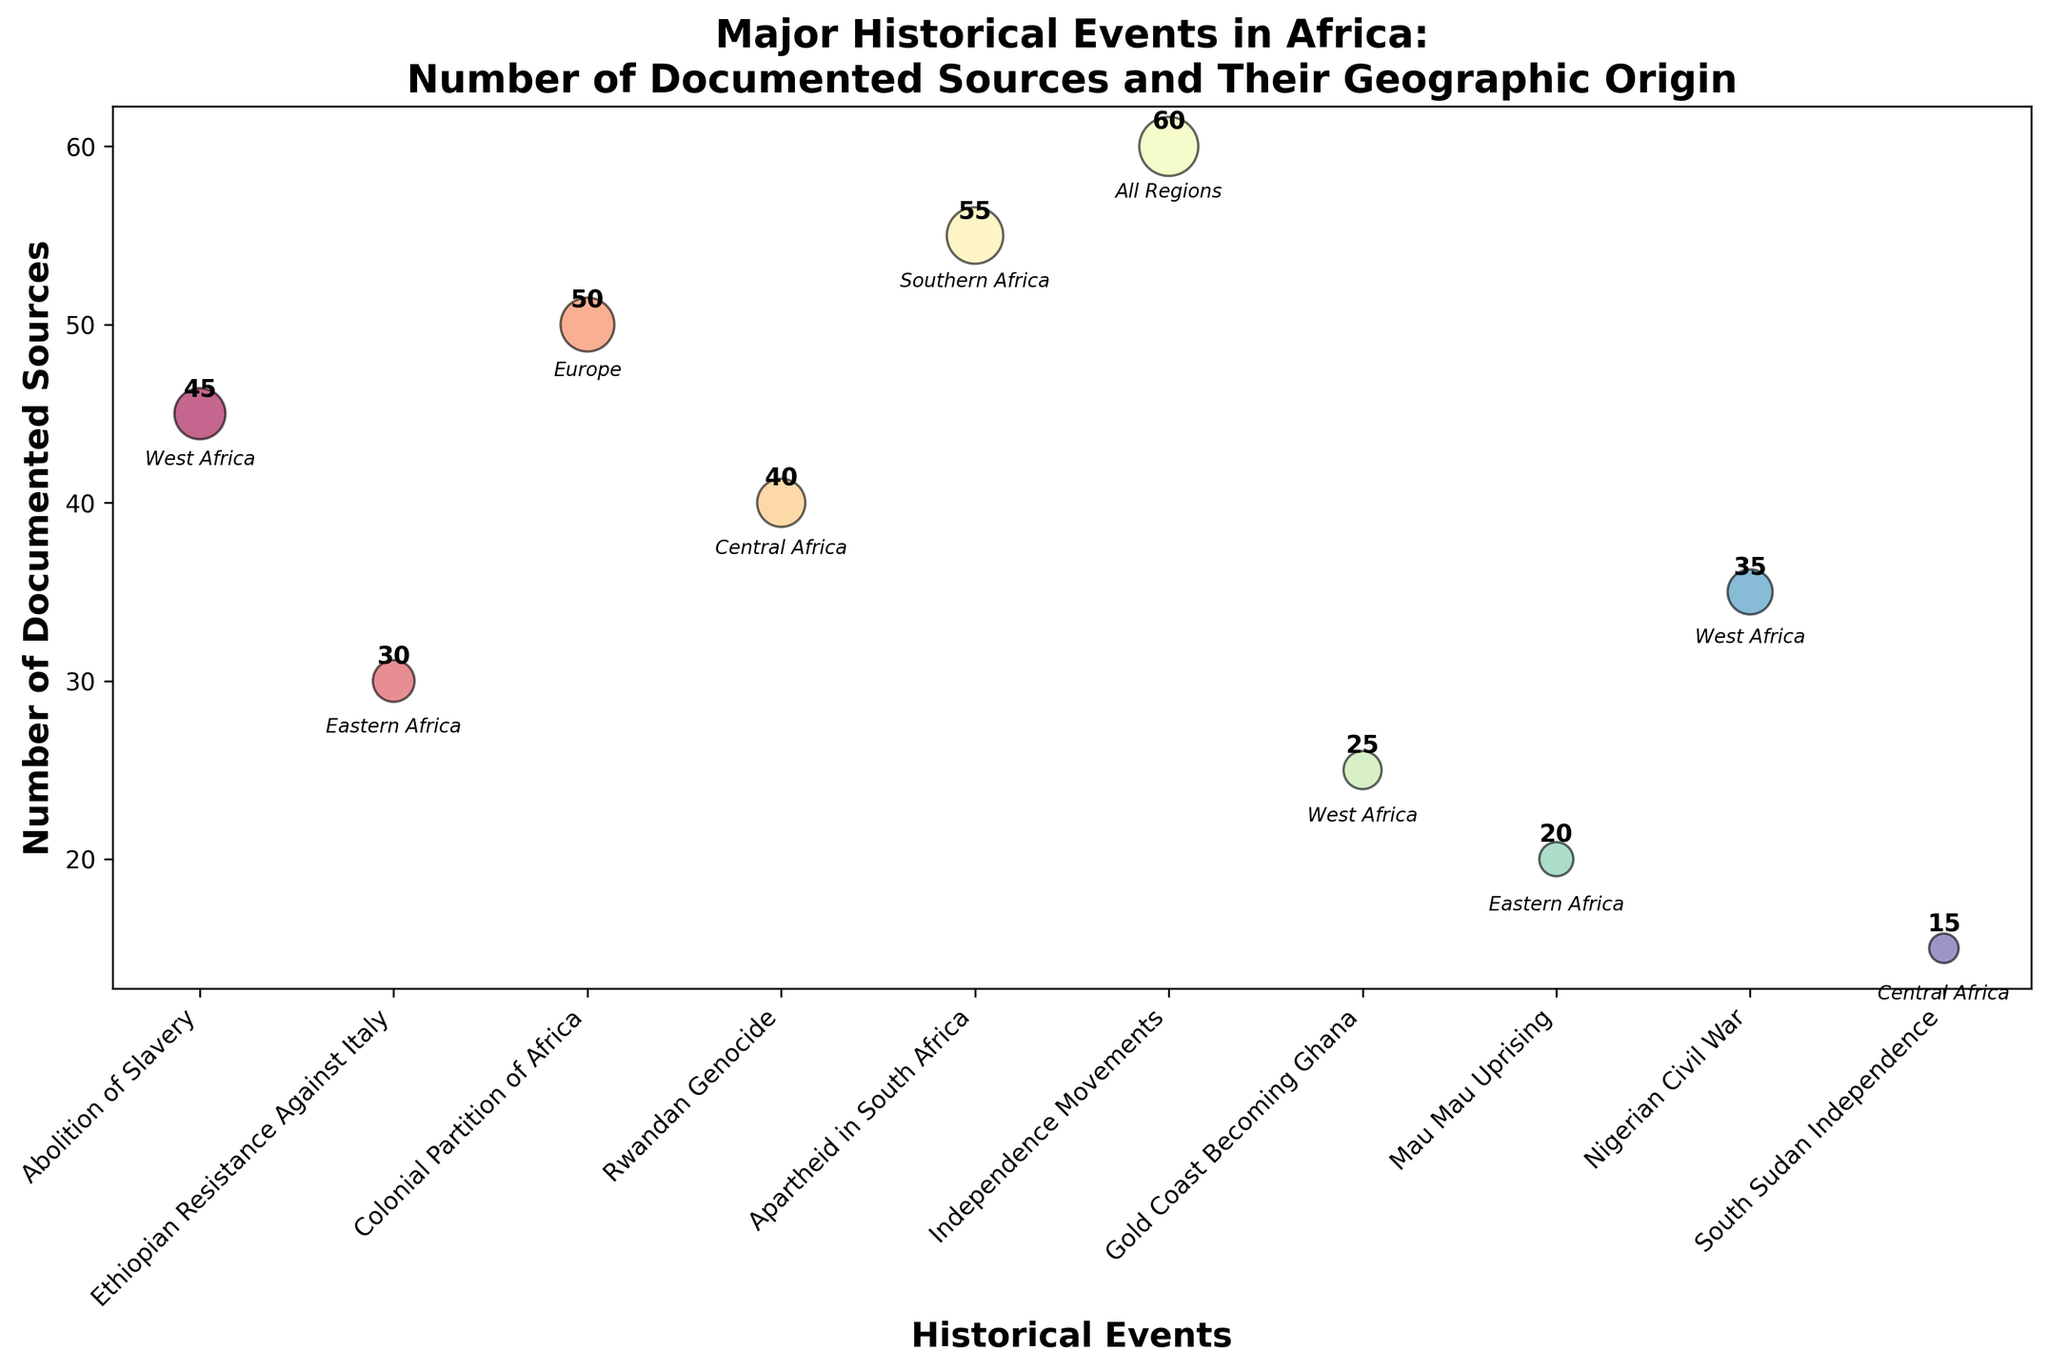what is the title of the chart? The title of the chart is displayed at the top of the figure. By reading it directly, we find that the title is "Major Historical Events in Africa: Number of Documented Sources and Their Geographic Origin."
Answer: Major Historical Events in Africa: Number of Documented Sources and Their Geographic Origin Which historical event has the most documented sources? By examining the y-axis (Number of Documented Sources) and comparing the sizes of the bubbles, the largest bubble indicates the event with the highest value. The "Independence Movements" event has the highest number of sources, with a value of 60.
Answer: Independence Movements What is the y-axis label on the chart? The y-axis label is shown along the vertical axis of the figure. It reads "Number of Documented Sources."
Answer: Number of Documented Sources How many sources document the Apartheid in South Africa event? Locate the bubble labeled "Apartheid in South Africa" and read its number of documented sources, which is annotated next to the bubble. It is 55.
Answer: 55 Are there more documented sources for the Ethiopian Resistance Against Italy or the Mau Mau Uprising? How many more? Compare the number of sources for both events. Ethiopian Resistance Against Italy has 30 sources, and the Mau Mau Uprising has 20 sources. The Ethiopian Resistance Against Italy has 10 more sources.
Answer: Ethiopian Resistance Against Italy has 10 more sources What is the average number of sources for events originating in West Africa? Calculate the average by summing the number of sources for "Abolition of Slavery" (45), "Gold Coast Becoming Ghana" (25), and "Nigerian Civil War" (35) and dividing by 3. The sum is 105, and the average is 105 / 3 = 35.
Answer: 35 Which event represents Central Africa’s origin and has the least number of documented sources? Central Africa has two events: "Rwandan Genocide" and "South Sudan Independence." By comparing their sources, "South Sudan Independence" has the least number of documented sources with 15.
Answer: South Sudan Independence How many events have a geographic origin in Eastern Africa? Count the bubbles labeled with the geographic origin "Eastern Africa". The events are "Ethiopian Resistance Against Italy" and "Mau Mau Uprising," totaling 2 events.
Answer: 2 Which geographic region is indicated by the event with the largest bubble? The largest bubble represents the event with the highest number of sources, which is "Independence Movements." The geographic origin for this event is "All Regions."
Answer: All Regions What is the combined number of documented sources for events originating in Central Africa? Sum the number of sources for "Rwandan Genocide" (40) and "South Sudan Independence" (15). The total number is 40 + 15 = 55.
Answer: 55 